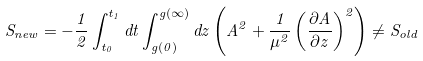Convert formula to latex. <formula><loc_0><loc_0><loc_500><loc_500>S _ { n e w } = - \frac { 1 } { 2 } \int _ { t _ { 0 } } ^ { t _ { 1 } } d t \int _ { g ( 0 ) } ^ { g ( \infty ) } d z \left ( A ^ { 2 } + \frac { 1 } { \mu ^ { 2 } } \left ( \frac { \partial A } { \partial z } \right ) ^ { 2 } \right ) \ne S _ { o l d }</formula> 